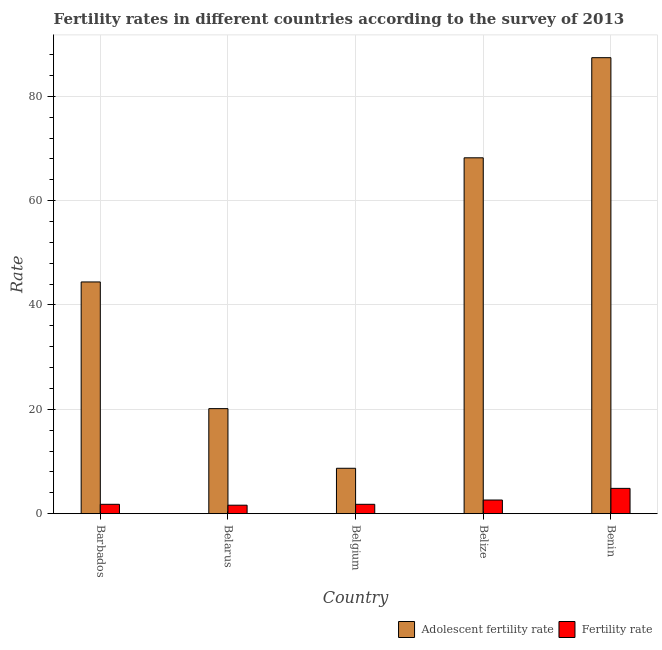How many different coloured bars are there?
Your response must be concise. 2. Are the number of bars on each tick of the X-axis equal?
Provide a succinct answer. Yes. What is the label of the 5th group of bars from the left?
Provide a succinct answer. Benin. In how many cases, is the number of bars for a given country not equal to the number of legend labels?
Make the answer very short. 0. What is the fertility rate in Benin?
Provide a short and direct response. 4.85. Across all countries, what is the maximum adolescent fertility rate?
Ensure brevity in your answer.  87.41. Across all countries, what is the minimum adolescent fertility rate?
Your answer should be compact. 8.7. In which country was the adolescent fertility rate maximum?
Your response must be concise. Benin. What is the total fertility rate in the graph?
Provide a short and direct response. 12.66. What is the difference between the fertility rate in Belgium and that in Belize?
Offer a terse response. -0.82. What is the difference between the adolescent fertility rate in Benin and the fertility rate in Belarus?
Provide a short and direct response. 85.78. What is the average adolescent fertility rate per country?
Your response must be concise. 45.77. What is the difference between the adolescent fertility rate and fertility rate in Belgium?
Offer a very short reply. 6.91. What is the ratio of the fertility rate in Belarus to that in Belize?
Make the answer very short. 0.62. What is the difference between the highest and the second highest adolescent fertility rate?
Your answer should be very brief. 19.19. What is the difference between the highest and the lowest adolescent fertility rate?
Provide a succinct answer. 78.71. In how many countries, is the fertility rate greater than the average fertility rate taken over all countries?
Your response must be concise. 2. Is the sum of the fertility rate in Belarus and Benin greater than the maximum adolescent fertility rate across all countries?
Offer a terse response. No. What does the 2nd bar from the left in Belize represents?
Keep it short and to the point. Fertility rate. What does the 1st bar from the right in Belgium represents?
Your response must be concise. Fertility rate. How many countries are there in the graph?
Ensure brevity in your answer.  5. What is the difference between two consecutive major ticks on the Y-axis?
Ensure brevity in your answer.  20. Are the values on the major ticks of Y-axis written in scientific E-notation?
Keep it short and to the point. No. Does the graph contain grids?
Your answer should be compact. Yes. Where does the legend appear in the graph?
Keep it short and to the point. Bottom right. What is the title of the graph?
Provide a short and direct response. Fertility rates in different countries according to the survey of 2013. What is the label or title of the X-axis?
Provide a succinct answer. Country. What is the label or title of the Y-axis?
Your answer should be very brief. Rate. What is the Rate of Adolescent fertility rate in Barbados?
Your answer should be very brief. 44.41. What is the Rate of Fertility rate in Barbados?
Your answer should be very brief. 1.79. What is the Rate of Adolescent fertility rate in Belarus?
Offer a very short reply. 20.13. What is the Rate in Fertility rate in Belarus?
Provide a short and direct response. 1.62. What is the Rate in Adolescent fertility rate in Belgium?
Offer a very short reply. 8.7. What is the Rate in Fertility rate in Belgium?
Ensure brevity in your answer.  1.79. What is the Rate of Adolescent fertility rate in Belize?
Offer a very short reply. 68.21. What is the Rate of Fertility rate in Belize?
Make the answer very short. 2.61. What is the Rate in Adolescent fertility rate in Benin?
Keep it short and to the point. 87.41. What is the Rate of Fertility rate in Benin?
Make the answer very short. 4.85. Across all countries, what is the maximum Rate of Adolescent fertility rate?
Offer a terse response. 87.41. Across all countries, what is the maximum Rate in Fertility rate?
Make the answer very short. 4.85. Across all countries, what is the minimum Rate of Adolescent fertility rate?
Provide a succinct answer. 8.7. Across all countries, what is the minimum Rate of Fertility rate?
Keep it short and to the point. 1.62. What is the total Rate in Adolescent fertility rate in the graph?
Ensure brevity in your answer.  228.86. What is the total Rate in Fertility rate in the graph?
Offer a very short reply. 12.66. What is the difference between the Rate of Adolescent fertility rate in Barbados and that in Belarus?
Provide a short and direct response. 24.29. What is the difference between the Rate of Fertility rate in Barbados and that in Belarus?
Your answer should be very brief. 0.17. What is the difference between the Rate of Adolescent fertility rate in Barbados and that in Belgium?
Ensure brevity in your answer.  35.72. What is the difference between the Rate in Adolescent fertility rate in Barbados and that in Belize?
Give a very brief answer. -23.8. What is the difference between the Rate of Fertility rate in Barbados and that in Belize?
Provide a succinct answer. -0.82. What is the difference between the Rate in Adolescent fertility rate in Barbados and that in Benin?
Offer a terse response. -42.99. What is the difference between the Rate of Fertility rate in Barbados and that in Benin?
Offer a terse response. -3.06. What is the difference between the Rate in Adolescent fertility rate in Belarus and that in Belgium?
Offer a very short reply. 11.43. What is the difference between the Rate of Fertility rate in Belarus and that in Belgium?
Ensure brevity in your answer.  -0.17. What is the difference between the Rate of Adolescent fertility rate in Belarus and that in Belize?
Your answer should be very brief. -48.08. What is the difference between the Rate of Fertility rate in Belarus and that in Belize?
Make the answer very short. -0.99. What is the difference between the Rate in Adolescent fertility rate in Belarus and that in Benin?
Give a very brief answer. -67.28. What is the difference between the Rate in Fertility rate in Belarus and that in Benin?
Ensure brevity in your answer.  -3.23. What is the difference between the Rate of Adolescent fertility rate in Belgium and that in Belize?
Your response must be concise. -59.51. What is the difference between the Rate of Fertility rate in Belgium and that in Belize?
Ensure brevity in your answer.  -0.82. What is the difference between the Rate in Adolescent fertility rate in Belgium and that in Benin?
Provide a succinct answer. -78.71. What is the difference between the Rate in Fertility rate in Belgium and that in Benin?
Your answer should be compact. -3.06. What is the difference between the Rate in Adolescent fertility rate in Belize and that in Benin?
Provide a succinct answer. -19.19. What is the difference between the Rate of Fertility rate in Belize and that in Benin?
Your answer should be compact. -2.23. What is the difference between the Rate of Adolescent fertility rate in Barbados and the Rate of Fertility rate in Belarus?
Provide a succinct answer. 42.79. What is the difference between the Rate of Adolescent fertility rate in Barbados and the Rate of Fertility rate in Belgium?
Your response must be concise. 42.62. What is the difference between the Rate of Adolescent fertility rate in Barbados and the Rate of Fertility rate in Belize?
Ensure brevity in your answer.  41.8. What is the difference between the Rate of Adolescent fertility rate in Barbados and the Rate of Fertility rate in Benin?
Provide a short and direct response. 39.57. What is the difference between the Rate in Adolescent fertility rate in Belarus and the Rate in Fertility rate in Belgium?
Make the answer very short. 18.34. What is the difference between the Rate of Adolescent fertility rate in Belarus and the Rate of Fertility rate in Belize?
Your answer should be very brief. 17.52. What is the difference between the Rate in Adolescent fertility rate in Belarus and the Rate in Fertility rate in Benin?
Ensure brevity in your answer.  15.28. What is the difference between the Rate in Adolescent fertility rate in Belgium and the Rate in Fertility rate in Belize?
Make the answer very short. 6.09. What is the difference between the Rate in Adolescent fertility rate in Belgium and the Rate in Fertility rate in Benin?
Keep it short and to the point. 3.85. What is the difference between the Rate in Adolescent fertility rate in Belize and the Rate in Fertility rate in Benin?
Offer a very short reply. 63.37. What is the average Rate in Adolescent fertility rate per country?
Provide a short and direct response. 45.77. What is the average Rate in Fertility rate per country?
Your response must be concise. 2.53. What is the difference between the Rate of Adolescent fertility rate and Rate of Fertility rate in Barbados?
Provide a short and direct response. 42.62. What is the difference between the Rate of Adolescent fertility rate and Rate of Fertility rate in Belarus?
Your answer should be very brief. 18.51. What is the difference between the Rate of Adolescent fertility rate and Rate of Fertility rate in Belgium?
Your answer should be compact. 6.91. What is the difference between the Rate of Adolescent fertility rate and Rate of Fertility rate in Belize?
Ensure brevity in your answer.  65.6. What is the difference between the Rate in Adolescent fertility rate and Rate in Fertility rate in Benin?
Offer a very short reply. 82.56. What is the ratio of the Rate of Adolescent fertility rate in Barbados to that in Belarus?
Your answer should be compact. 2.21. What is the ratio of the Rate of Fertility rate in Barbados to that in Belarus?
Your answer should be very brief. 1.11. What is the ratio of the Rate of Adolescent fertility rate in Barbados to that in Belgium?
Offer a terse response. 5.11. What is the ratio of the Rate of Fertility rate in Barbados to that in Belgium?
Give a very brief answer. 1. What is the ratio of the Rate of Adolescent fertility rate in Barbados to that in Belize?
Make the answer very short. 0.65. What is the ratio of the Rate of Fertility rate in Barbados to that in Belize?
Offer a very short reply. 0.69. What is the ratio of the Rate in Adolescent fertility rate in Barbados to that in Benin?
Make the answer very short. 0.51. What is the ratio of the Rate of Fertility rate in Barbados to that in Benin?
Provide a short and direct response. 0.37. What is the ratio of the Rate in Adolescent fertility rate in Belarus to that in Belgium?
Ensure brevity in your answer.  2.31. What is the ratio of the Rate of Fertility rate in Belarus to that in Belgium?
Offer a very short reply. 0.91. What is the ratio of the Rate in Adolescent fertility rate in Belarus to that in Belize?
Give a very brief answer. 0.3. What is the ratio of the Rate in Fertility rate in Belarus to that in Belize?
Provide a succinct answer. 0.62. What is the ratio of the Rate in Adolescent fertility rate in Belarus to that in Benin?
Provide a succinct answer. 0.23. What is the ratio of the Rate of Fertility rate in Belarus to that in Benin?
Your answer should be compact. 0.33. What is the ratio of the Rate in Adolescent fertility rate in Belgium to that in Belize?
Keep it short and to the point. 0.13. What is the ratio of the Rate of Fertility rate in Belgium to that in Belize?
Make the answer very short. 0.69. What is the ratio of the Rate in Adolescent fertility rate in Belgium to that in Benin?
Your answer should be compact. 0.1. What is the ratio of the Rate in Fertility rate in Belgium to that in Benin?
Keep it short and to the point. 0.37. What is the ratio of the Rate in Adolescent fertility rate in Belize to that in Benin?
Your answer should be very brief. 0.78. What is the ratio of the Rate in Fertility rate in Belize to that in Benin?
Offer a terse response. 0.54. What is the difference between the highest and the second highest Rate of Adolescent fertility rate?
Offer a terse response. 19.19. What is the difference between the highest and the second highest Rate of Fertility rate?
Give a very brief answer. 2.23. What is the difference between the highest and the lowest Rate in Adolescent fertility rate?
Ensure brevity in your answer.  78.71. What is the difference between the highest and the lowest Rate in Fertility rate?
Your answer should be compact. 3.23. 